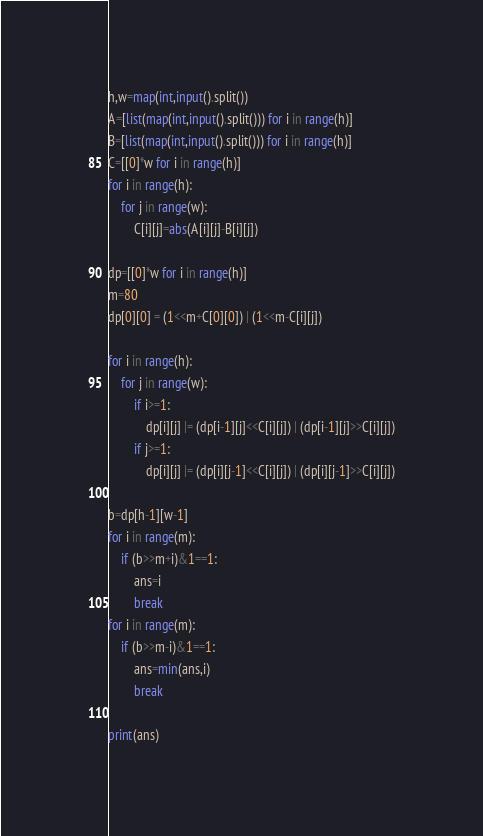<code> <loc_0><loc_0><loc_500><loc_500><_Python_>h,w=map(int,input().split())
A=[list(map(int,input().split())) for i in range(h)]
B=[list(map(int,input().split())) for i in range(h)]
C=[[0]*w for i in range(h)]
for i in range(h):
    for j in range(w):
        C[i][j]=abs(A[i][j]-B[i][j])
    
dp=[[0]*w for i in range(h)]
m=80
dp[0][0] = (1<<m+C[0][0]) | (1<<m-C[i][j])

for i in range(h):
    for j in range(w):
        if i>=1:
            dp[i][j] |= (dp[i-1][j]<<C[i][j]) | (dp[i-1][j]>>C[i][j])
        if j>=1:
            dp[i][j] |= (dp[i][j-1]<<C[i][j]) | (dp[i][j-1]>>C[i][j])
        
b=dp[h-1][w-1]
for i in range(m):
    if (b>>m+i)&1==1:
        ans=i
        break
for i in range(m):
    if (b>>m-i)&1==1:
        ans=min(ans,i)
        break

print(ans)</code> 